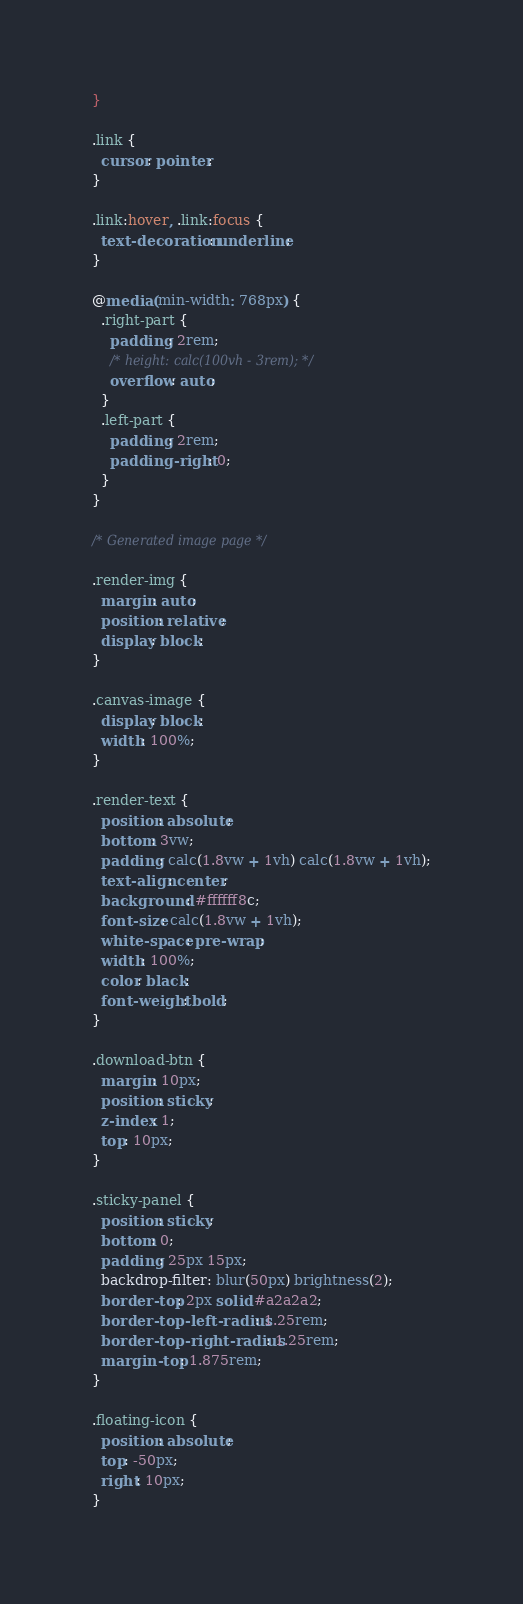<code> <loc_0><loc_0><loc_500><loc_500><_CSS_>}

.link {
  cursor: pointer;
}

.link:hover, .link:focus {
  text-decoration: underline;
}

@media (min-width: 768px) {
  .right-part {
    padding: 2rem;
    /* height: calc(100vh - 3rem); */
    overflow: auto;
  }
  .left-part {
    padding: 2rem;
    padding-right: 0;
  }
}

/* Generated image page */

.render-img {
  margin: auto;
  position: relative;
  display: block;
}

.canvas-image {
  display: block;
  width: 100%;
}

.render-text {
  position: absolute;
  bottom: 3vw;
  padding: calc(1.8vw + 1vh) calc(1.8vw + 1vh);
  text-align: center;
  background: #ffffff8c;
  font-size: calc(1.8vw + 1vh);
  white-space: pre-wrap;
  width: 100%;
  color: black;
  font-weight: bold;
}

.download-btn {
  margin: 10px;
  position: sticky;
  z-index: 1;
  top: 10px;
}

.sticky-panel {
  position: sticky;
  bottom: 0;
  padding: 25px 15px;
  backdrop-filter: blur(50px) brightness(2);
  border-top: 2px solid #a2a2a2;
  border-top-left-radius: 1.25rem;
  border-top-right-radius: 1.25rem;
  margin-top: 1.875rem;
}

.floating-icon {
  position: absolute;
  top: -50px;
  right: 10px;
}</code> 